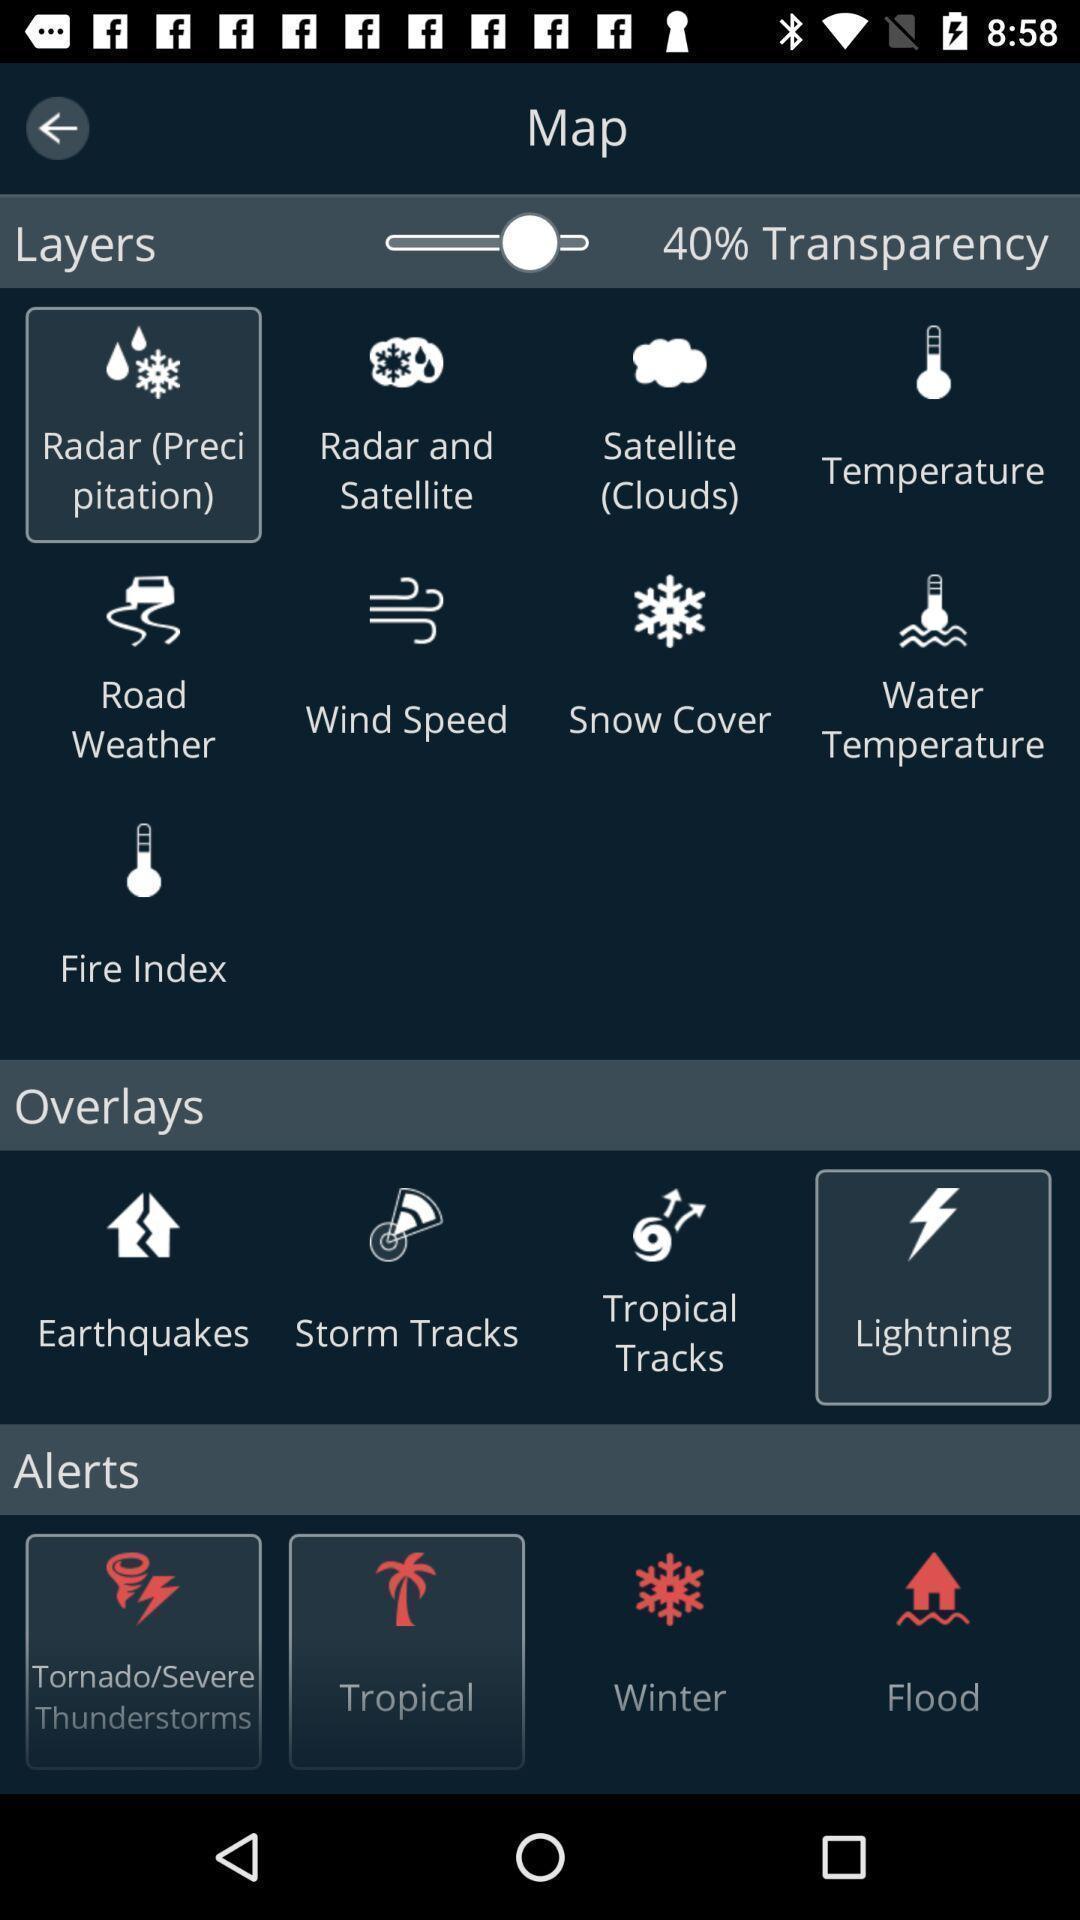What can you discern from this picture? Screen shows a page of current weather conditions. 